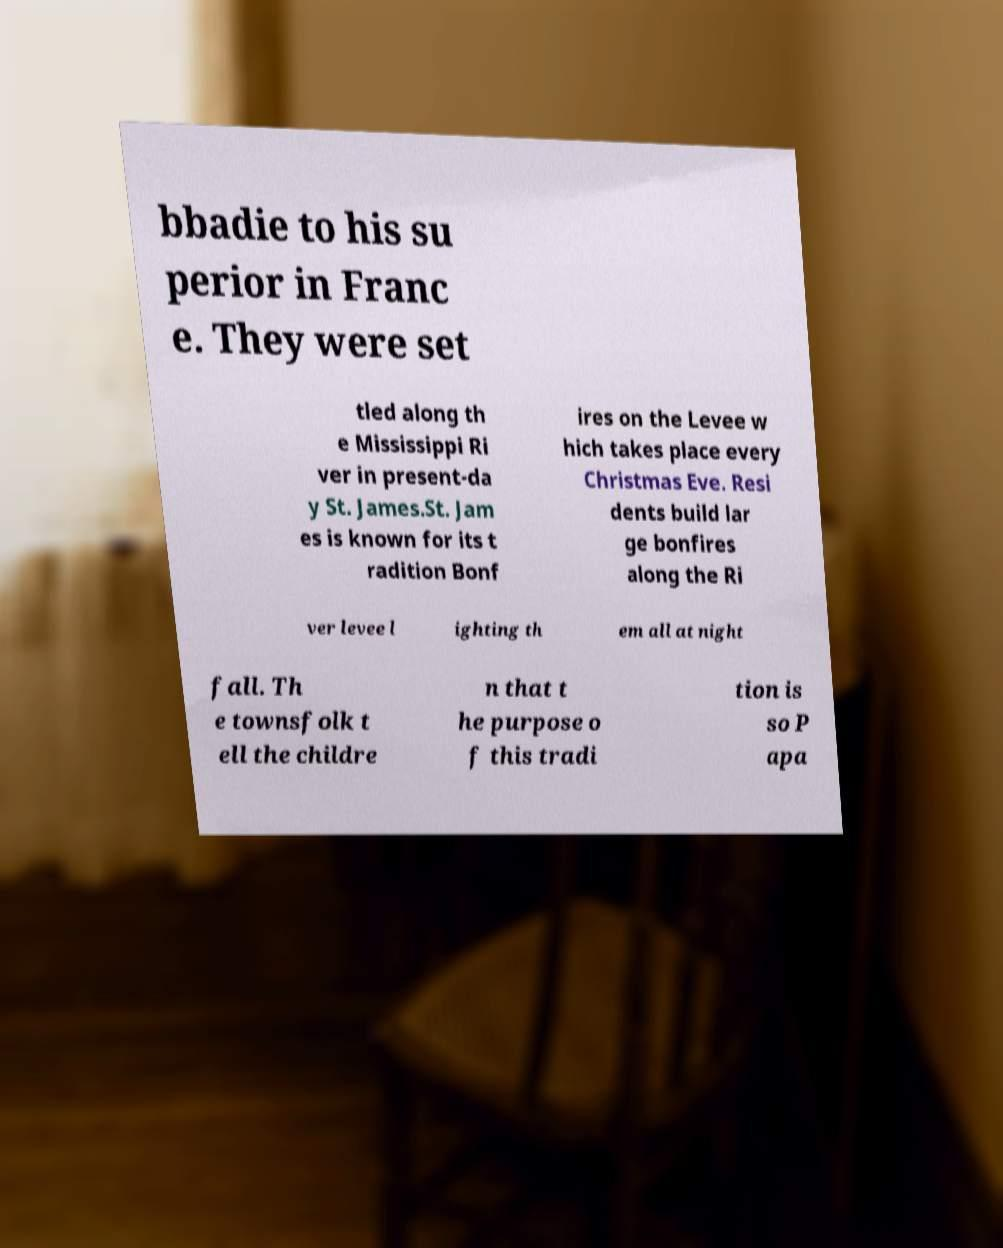Please read and relay the text visible in this image. What does it say? bbadie to his su perior in Franc e. They were set tled along th e Mississippi Ri ver in present-da y St. James.St. Jam es is known for its t radition Bonf ires on the Levee w hich takes place every Christmas Eve. Resi dents build lar ge bonfires along the Ri ver levee l ighting th em all at night fall. Th e townsfolk t ell the childre n that t he purpose o f this tradi tion is so P apa 